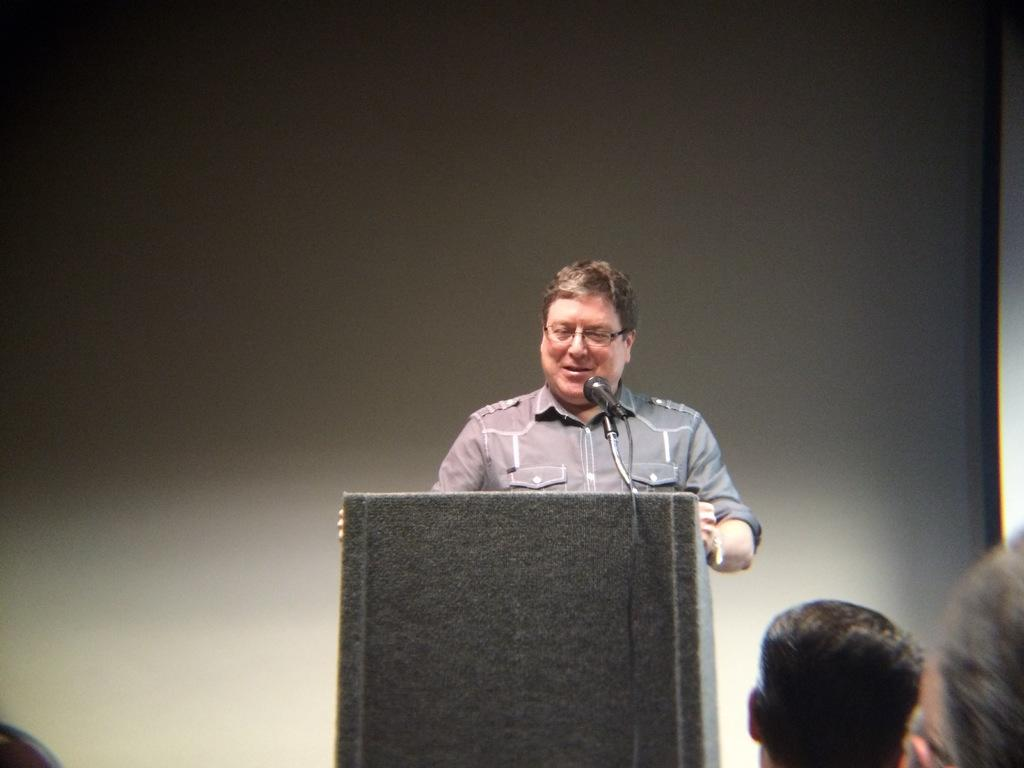How many people are in the image? There are people in the image, but the exact number is not specified. What is one person doing in the image? One person is standing in the image. What object is present in the image that is typically used for speeches or presentations? There is a podium in the image. What device is present in the image that is used for amplifying sound? There is a microphone in the image. What can be seen behind the people and objects in the image? The background is visible in the image. How many dinosaurs are present in the image? There are no dinosaurs present in the image. What type of fairies can be seen flying around the people in the image? There are no fairies present in the image. 